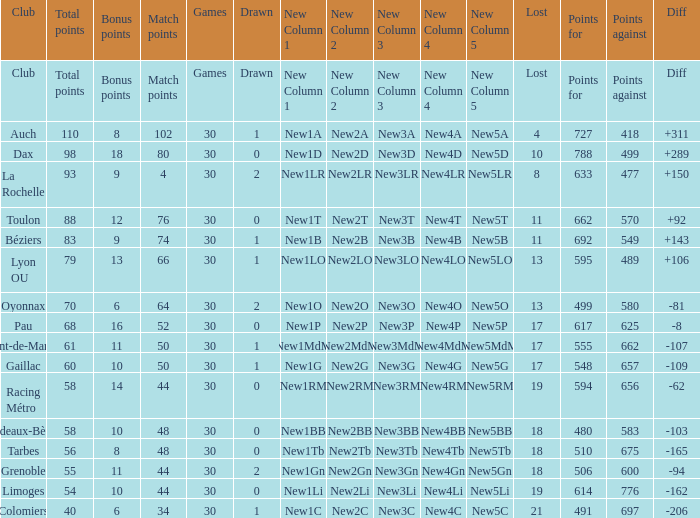What is the amount of match points for a club that lost 18 and has 11 bonus points? 44.0. Parse the table in full. {'header': ['Club', 'Total points', 'Bonus points', 'Match points', 'Games', 'Drawn', 'New Column 1', 'New Column 2', 'New Column 3', 'New Column 4', 'New Column 5', 'Lost', 'Points for', 'Points against', 'Diff'], 'rows': [['Club', 'Total points', 'Bonus points', 'Match points', 'Games', 'Drawn', 'New Column 1', 'New Column 2', 'New Column 3', 'New Column 4', 'New Column 5', 'Lost', 'Points for', 'Points against', 'Diff'], ['Auch', '110', '8', '102', '30', '1', 'New1A', 'New2A', 'New3A', 'New4A', 'New5A', '4', '727', '418', '+311'], ['Dax', '98', '18', '80', '30', '0', 'New1D', 'New2D', 'New3D', 'New4D', 'New5D', '10', '788', '499', '+289'], ['La Rochelle', '93', '9', '4', '30', '2', 'New1LR', 'New2LR', 'New3LR', 'New4LR', 'New5LR', '8', '633', '477', '+150'], ['Toulon', '88', '12', '76', '30', '0', 'New1T', 'New2T', 'New3T', 'New4T', 'New5T', '11', '662', '570', '+92'], ['Béziers', '83', '9', '74', '30', '1', 'New1B', 'New2B', 'New3B', 'New4B', 'New5B', '11', '692', '549', '+143'], ['Lyon OU', '79', '13', '66', '30', '1', 'New1LO', 'New2LO', 'New3LO', 'New4LO', 'New5LO', '13', '595', '489', '+106'], ['Oyonnax', '70', '6', '64', '30', '2', 'New1O', 'New2O', 'New3O', 'New4O', 'New5O', '13', '499', '580', '-81'], ['Pau', '68', '16', '52', '30', '0', 'New1P', 'New2P', 'New3P', 'New4P', 'New5P', '17', '617', '625', '-8'], ['Mont-de-Marsan', '61', '11', '50', '30', '1', 'New1MdM', 'New2MdM', 'New3MdM', 'New4MdM', 'New5MdM', '17', '555', '662', '-107'], ['Gaillac', '60', '10', '50', '30', '1', 'New1G', 'New2G', 'New3G', 'New4G', 'New5G', '17', '548', '657', '-109'], ['Racing Métro', '58', '14', '44', '30', '0', 'New1RM', 'New2RM', 'New3RM', 'New4RM', 'New5RM', '19', '594', '656', '-62'], ['Bordeaux-Bègles', '58', '10', '48', '30', '0', 'New1BB', 'New2BB', 'New3BB', 'New4BB', 'New5BB', '18', '480', '583', '-103'], ['Tarbes', '56', '8', '48', '30', '0', 'New1Tb', 'New2Tb', 'New3Tb', 'New4Tb', 'New5Tb', '18', '510', '675', '-165'], ['Grenoble', '55', '11', '44', '30', '2', 'New1Gn', 'New2Gn', 'New3Gn', 'New4Gn', 'New5Gn', '18', '506', '600', '-94'], ['Limoges', '54', '10', '44', '30', '0', 'New1Li', 'New2Li', 'New3Li', 'New4Li', 'New5Li', '19', '614', '776', '-162'], ['Colomiers', '40', '6', '34', '30', '1', 'New1C', 'New2C', 'New3C', 'New4C', 'New5C', '21', '491', '697', '-206']]} 